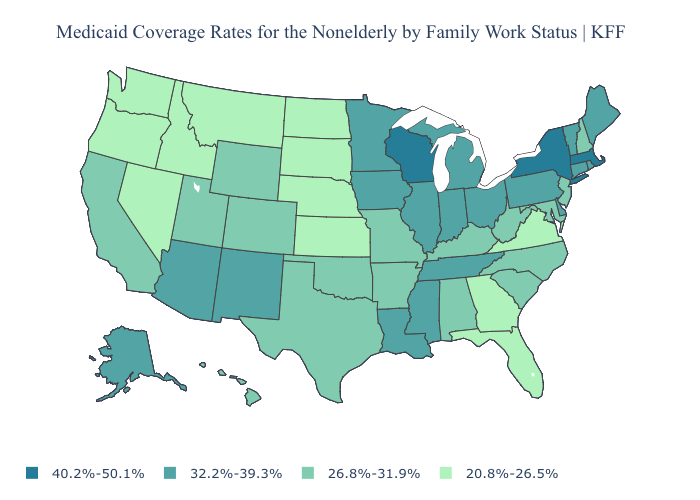Does the first symbol in the legend represent the smallest category?
Short answer required. No. Among the states that border Washington , which have the highest value?
Give a very brief answer. Idaho, Oregon. Does Georgia have the lowest value in the USA?
Short answer required. Yes. Name the states that have a value in the range 32.2%-39.3%?
Short answer required. Alaska, Arizona, Connecticut, Delaware, Illinois, Indiana, Iowa, Louisiana, Maine, Michigan, Minnesota, Mississippi, New Mexico, Ohio, Pennsylvania, Rhode Island, Tennessee, Vermont. Name the states that have a value in the range 32.2%-39.3%?
Be succinct. Alaska, Arizona, Connecticut, Delaware, Illinois, Indiana, Iowa, Louisiana, Maine, Michigan, Minnesota, Mississippi, New Mexico, Ohio, Pennsylvania, Rhode Island, Tennessee, Vermont. What is the value of North Dakota?
Give a very brief answer. 20.8%-26.5%. Among the states that border Nevada , does Oregon have the lowest value?
Quick response, please. Yes. What is the highest value in the South ?
Answer briefly. 32.2%-39.3%. Does Wyoming have a lower value than Delaware?
Be succinct. Yes. Among the states that border Louisiana , does Texas have the lowest value?
Keep it brief. Yes. How many symbols are there in the legend?
Concise answer only. 4. Name the states that have a value in the range 20.8%-26.5%?
Short answer required. Florida, Georgia, Idaho, Kansas, Montana, Nebraska, Nevada, North Dakota, Oregon, South Dakota, Virginia, Washington. Does Washington have the same value as Montana?
Write a very short answer. Yes. Does Montana have the same value as Maryland?
Be succinct. No. Does the first symbol in the legend represent the smallest category?
Be succinct. No. 